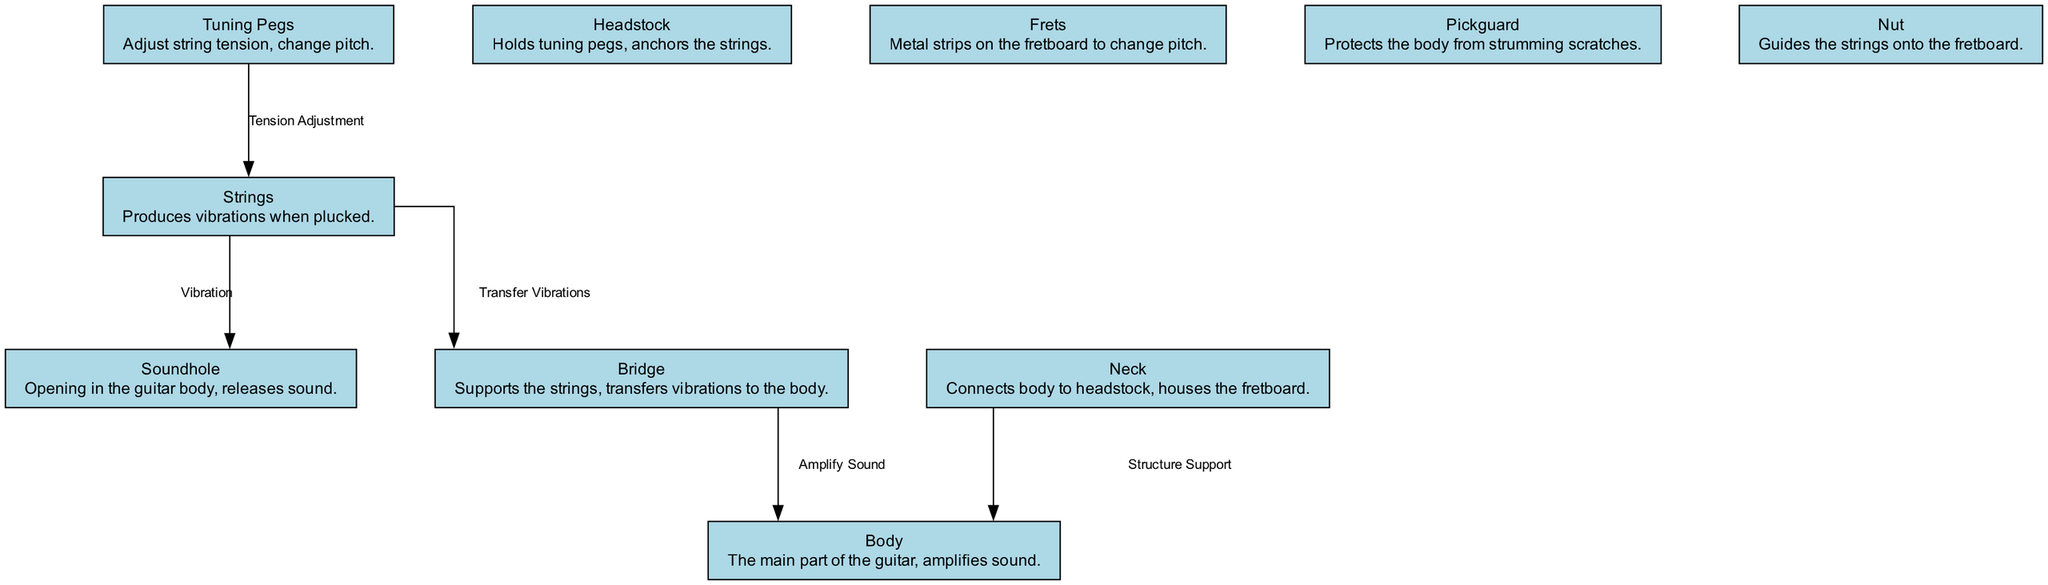What is the main part of the guitar that amplifies sound? The diagram identifies the "Body" as the main part of the guitar responsible for amplifying sound.
Answer: Body How many nodes are present in the diagram? The diagram lists a total of 10 nodes, each representing different parts of the acoustic guitar.
Answer: 10 What part guides the strings onto the fretboard? According to the diagram, the "Nut" is responsible for guiding the strings onto the fretboard.
Answer: Nut What component holds the tuning pegs? The "Headstock" is labeled in the diagram as the component that holds the tuning pegs.
Answer: Headstock Which part of the guitar transfers vibrations to the body? The diagram shows that the "Bridge" takes on the role of transferring vibrations from the strings to the body of the guitar.
Answer: Bridge What is the function of the soundhole? The soundhole is described in the diagram as the opening in the guitar body that releases sound.
Answer: Releases sound How does the bridge amplify sound? The diagram explains that vibrations are transferred from the strings to the bridge, which then amplifies the sound by sending it into the body.
Answer: Amplifies sound Which element adjusts string tension? The "Tuning Pegs" are designated in the diagram as the element that adjusts the tension of the strings, directly affecting pitch.
Answer: Tension adjustment What material is likely applied to protect the guitar body during strumming? The diagram indicates that the "Pickguard" protects the guitar body from scratches that occur while strumming.
Answer: Pickguard 